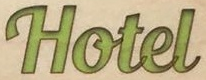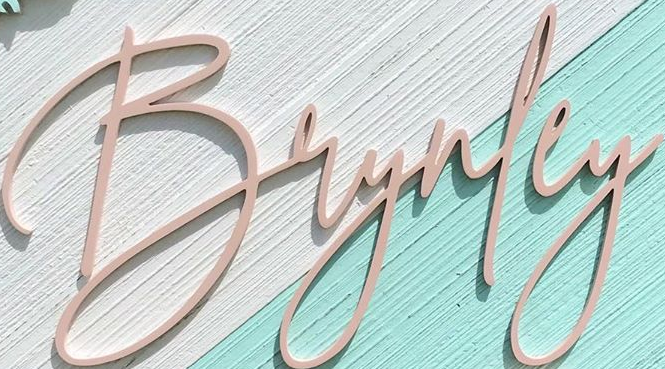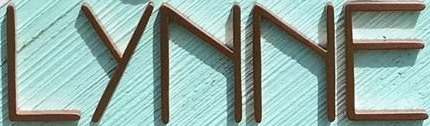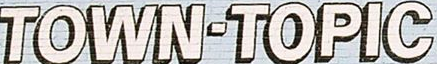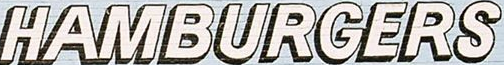Transcribe the words shown in these images in order, separated by a semicolon. Hotel; Brynley; LYNNE; TOWN-TOPIC; HAMBURGERS 